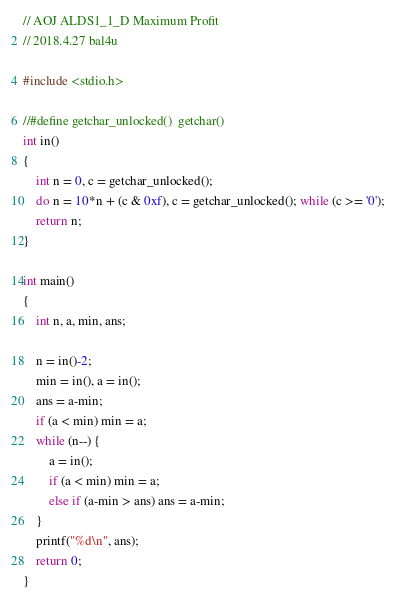Convert code to text. <code><loc_0><loc_0><loc_500><loc_500><_C_>// AOJ ALDS1_1_D Maximum Profit
// 2018.4.27 bal4u

#include <stdio.h>

//#define getchar_unlocked()  getchar()
int in()
{
	int n = 0, c = getchar_unlocked();
	do n = 10*n + (c & 0xf), c = getchar_unlocked(); while (c >= '0');
	return n;
}

int main()
{
	int n, a, min, ans;

	n = in()-2;
	min = in(), a = in();
	ans = a-min;
	if (a < min) min = a;
	while (n--) {
		a = in();
		if (a < min) min = a;
		else if (a-min > ans) ans = a-min;
	}
	printf("%d\n", ans);
	return 0;
}

</code> 